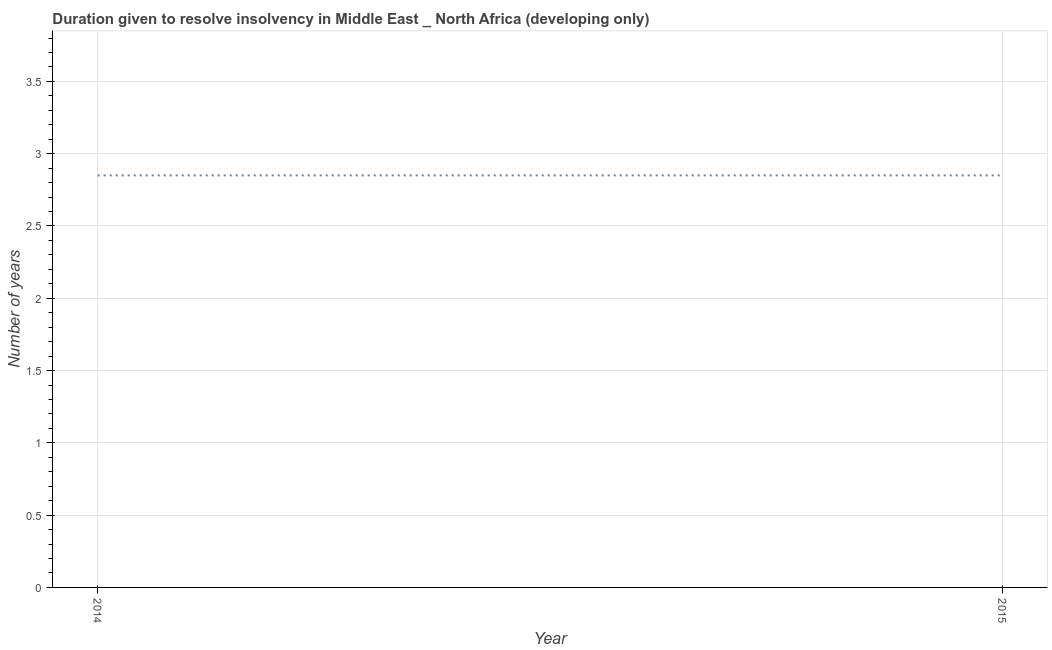What is the number of years to resolve insolvency in 2014?
Give a very brief answer. 2.85. Across all years, what is the maximum number of years to resolve insolvency?
Offer a very short reply. 2.85. Across all years, what is the minimum number of years to resolve insolvency?
Provide a succinct answer. 2.85. What is the sum of the number of years to resolve insolvency?
Provide a short and direct response. 5.7. What is the average number of years to resolve insolvency per year?
Ensure brevity in your answer.  2.85. What is the median number of years to resolve insolvency?
Ensure brevity in your answer.  2.85. Do a majority of the years between 2015 and 2014 (inclusive) have number of years to resolve insolvency greater than 1.2 ?
Your answer should be compact. No. What is the ratio of the number of years to resolve insolvency in 2014 to that in 2015?
Keep it short and to the point. 1. Does the number of years to resolve insolvency monotonically increase over the years?
Provide a succinct answer. No. How many lines are there?
Make the answer very short. 1. How many years are there in the graph?
Ensure brevity in your answer.  2. What is the title of the graph?
Provide a short and direct response. Duration given to resolve insolvency in Middle East _ North Africa (developing only). What is the label or title of the X-axis?
Your answer should be very brief. Year. What is the label or title of the Y-axis?
Provide a short and direct response. Number of years. What is the Number of years of 2014?
Your answer should be compact. 2.85. What is the Number of years in 2015?
Your answer should be compact. 2.85. What is the difference between the Number of years in 2014 and 2015?
Make the answer very short. 0. What is the ratio of the Number of years in 2014 to that in 2015?
Your answer should be very brief. 1. 